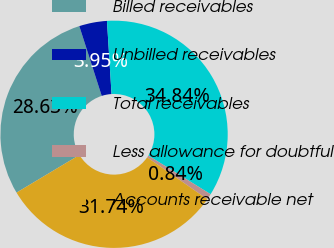Convert chart to OTSL. <chart><loc_0><loc_0><loc_500><loc_500><pie_chart><fcel>Billed receivables<fcel>Unbilled receivables<fcel>Total receivables<fcel>Less allowance for doubtful<fcel>Accounts receivable net<nl><fcel>28.63%<fcel>3.95%<fcel>34.84%<fcel>0.84%<fcel>31.74%<nl></chart> 